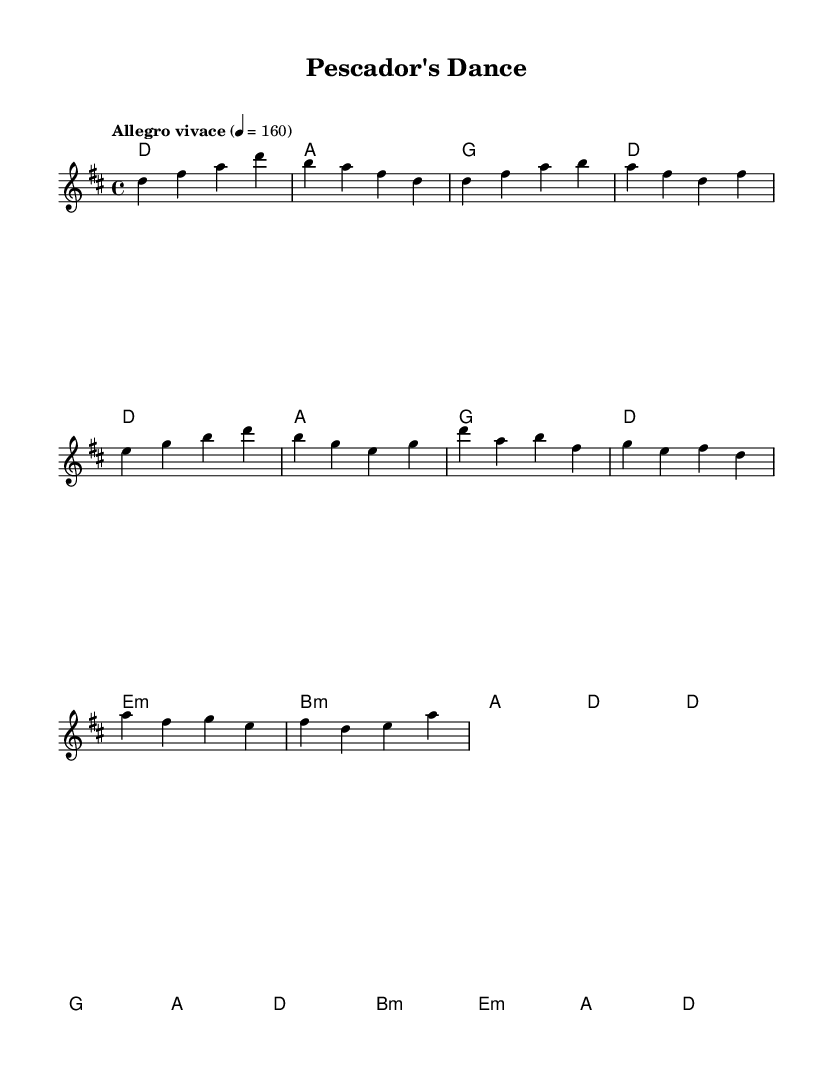What is the key signature of this music? The key signature is D major, which has two sharps: F# and C#.
Answer: D major What is the time signature of this music? The time signature is 4/4, indicating four beats per measure.
Answer: 4/4 What is the tempo marking of this piece? The tempo marking is "Allegro vivace," indicating a lively and brisk pace.
Answer: Allegro vivace How many measures are there in the verse section? The verse consists of two measures in the sheet music, clearly identifiable by the melody.
Answer: 2 What is the primary chord used in the introduction? The primary chord in the introduction is D major, as seen in the chord progression.
Answer: D What is the function of the seagull sounds in Latin dance music? They add a playful element, enhancing the lively and vibrant atmosphere typical of such music.
Answer: Playful element Which section of the music is more energetic, the verse or the chorus? The chorus is designed to be more energetic with a more pronounced rhythm and melody compared to the verse.
Answer: Chorus 